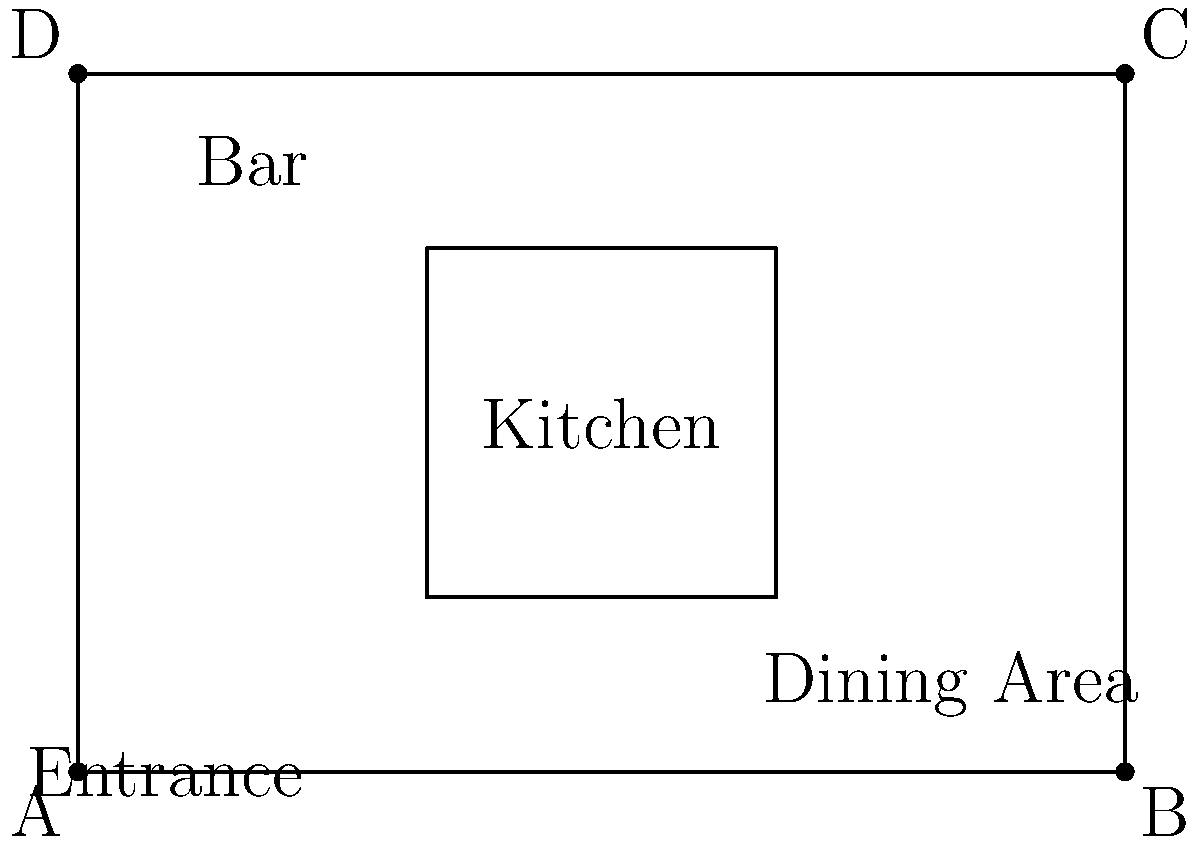In your restaurant layout, a customer needs to walk from the entrance (point A) to the bar, then to the kitchen, and finally to a table in the dining area (point B). If the restaurant is 60 feet wide and 40 feet long, and assuming the customer walks in straight lines between each destination, what is the total distance traveled in feet? Let's break this down step-by-step:

1) First, we need to determine the scale of the diagram. We know the restaurant is 60 feet wide and 40 feet long.
   In the diagram, the width is 6 units and the length is 4 units.
   So, 1 unit in the diagram = 10 feet in reality.

2) Now, let's calculate each segment of the path:
   a) Entrance (A) to Bar: 
      The bar is located at (1, 3.5) in the diagram.
      Distance = $\sqrt{(1-0)^2 + (3.5-0)^2} = \sqrt{1 + 12.25} = \sqrt{13.25} \approx 3.64$ units
      In feet: $3.64 \times 10 = 36.4$ feet

   b) Bar to Kitchen:
      The kitchen center is at (3, 2) in the diagram.
      Distance = $\sqrt{(3-1)^2 + (2-3.5)^2} = \sqrt{4 + 2.25} = \sqrt{6.25} = 2.5$ units
      In feet: $2.5 \times 10 = 25$ feet

   c) Kitchen to Dining Area (B):
      Point B is at (6, 0) in the diagram.
      Distance = $\sqrt{(6-3)^2 + (0-2)^2} = \sqrt{9 + 4} = \sqrt{13} \approx 3.61$ units
      In feet: $3.61 \times 10 = 36.1$ feet

3) Total distance:
   $36.4 + 25 + 36.1 = 97.5$ feet

Therefore, the total distance traveled by the customer is approximately 97.5 feet.
Answer: 97.5 feet 